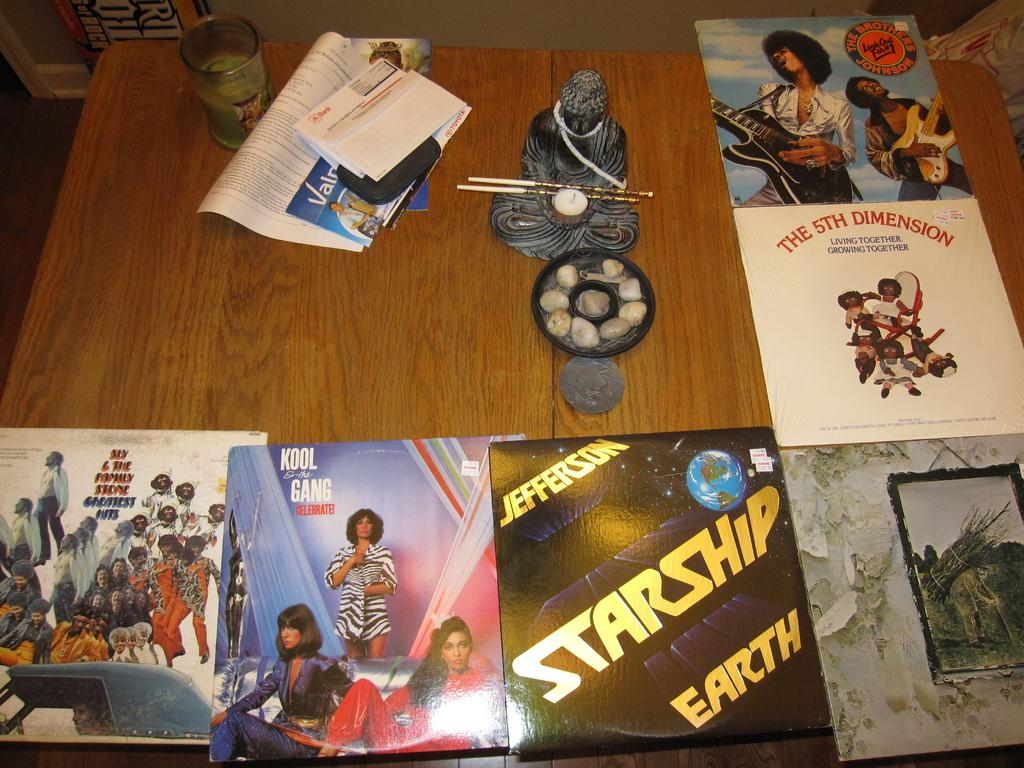What piece of furniture is present in the image? There is a table in the image. What items can be seen on the table? There is a book, papers, a glass, and a laughing buddha on the table. What type of decoration is present in the image? There are posters in the image. How many babies are present in the image? There are no babies present in the image. What type of amusement can be seen in the image? There is no amusement present in the image; it features a table with various items on it and posters on the wall. 